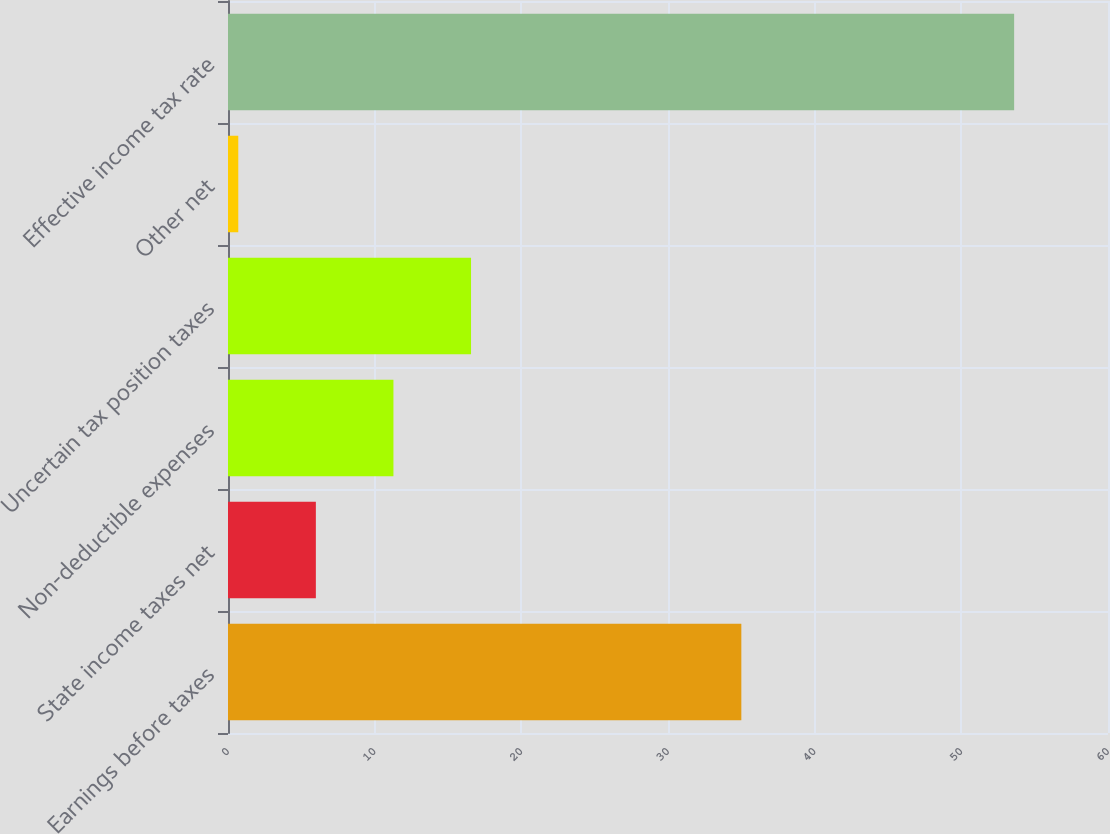Convert chart. <chart><loc_0><loc_0><loc_500><loc_500><bar_chart><fcel>Earnings before taxes<fcel>State income taxes net<fcel>Non-deductible expenses<fcel>Uncertain tax position taxes<fcel>Other net<fcel>Effective income tax rate<nl><fcel>35<fcel>5.99<fcel>11.28<fcel>16.57<fcel>0.7<fcel>53.6<nl></chart> 